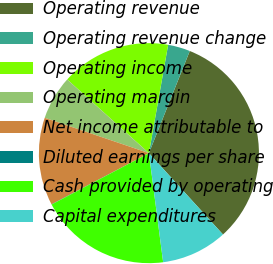<chart> <loc_0><loc_0><loc_500><loc_500><pie_chart><fcel>Operating revenue<fcel>Operating revenue change<fcel>Operating income<fcel>Operating margin<fcel>Net income attributable to<fcel>Diluted earnings per share<fcel>Cash provided by operating<fcel>Capital expenditures<nl><fcel>32.19%<fcel>3.26%<fcel>16.12%<fcel>6.47%<fcel>12.9%<fcel>0.04%<fcel>19.33%<fcel>9.69%<nl></chart> 